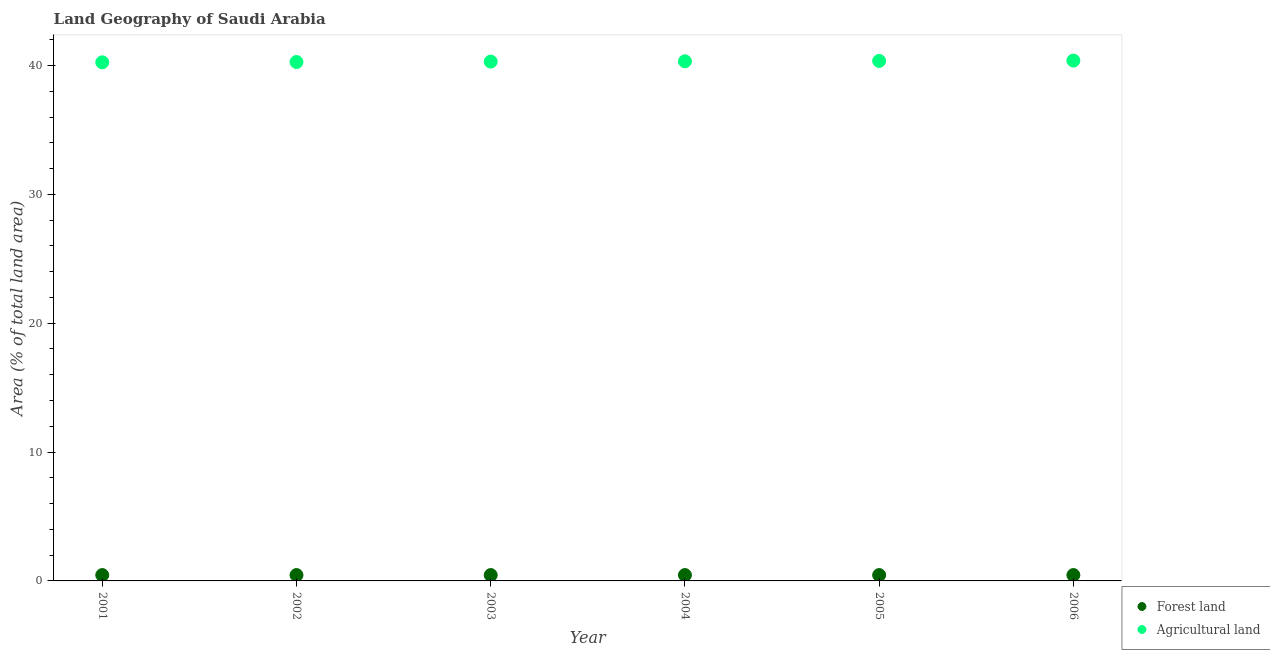What is the percentage of land area under forests in 2003?
Offer a terse response. 0.45. Across all years, what is the maximum percentage of land area under agriculture?
Make the answer very short. 40.38. Across all years, what is the minimum percentage of land area under agriculture?
Your answer should be very brief. 40.25. What is the total percentage of land area under forests in the graph?
Keep it short and to the point. 2.73. What is the difference between the percentage of land area under forests in 2003 and that in 2006?
Offer a very short reply. 0. What is the difference between the percentage of land area under agriculture in 2001 and the percentage of land area under forests in 2005?
Ensure brevity in your answer.  39.79. What is the average percentage of land area under agriculture per year?
Provide a succinct answer. 40.31. In the year 2006, what is the difference between the percentage of land area under forests and percentage of land area under agriculture?
Offer a very short reply. -39.93. What is the ratio of the percentage of land area under agriculture in 2002 to that in 2006?
Your response must be concise. 1. Is the percentage of land area under agriculture in 2003 less than that in 2004?
Ensure brevity in your answer.  Yes. Is the difference between the percentage of land area under agriculture in 2002 and 2005 greater than the difference between the percentage of land area under forests in 2002 and 2005?
Ensure brevity in your answer.  No. What is the difference between the highest and the lowest percentage of land area under forests?
Give a very brief answer. 0. In how many years, is the percentage of land area under agriculture greater than the average percentage of land area under agriculture taken over all years?
Your answer should be compact. 3. Is the percentage of land area under forests strictly greater than the percentage of land area under agriculture over the years?
Make the answer very short. No. How many years are there in the graph?
Your answer should be very brief. 6. Where does the legend appear in the graph?
Give a very brief answer. Bottom right. What is the title of the graph?
Your answer should be compact. Land Geography of Saudi Arabia. Does "Private credit bureau" appear as one of the legend labels in the graph?
Your response must be concise. No. What is the label or title of the X-axis?
Offer a very short reply. Year. What is the label or title of the Y-axis?
Offer a very short reply. Area (% of total land area). What is the Area (% of total land area) in Forest land in 2001?
Make the answer very short. 0.45. What is the Area (% of total land area) of Agricultural land in 2001?
Offer a terse response. 40.25. What is the Area (% of total land area) in Forest land in 2002?
Make the answer very short. 0.45. What is the Area (% of total land area) in Agricultural land in 2002?
Provide a succinct answer. 40.27. What is the Area (% of total land area) of Forest land in 2003?
Provide a short and direct response. 0.45. What is the Area (% of total land area) in Agricultural land in 2003?
Your response must be concise. 40.3. What is the Area (% of total land area) of Forest land in 2004?
Offer a terse response. 0.45. What is the Area (% of total land area) in Agricultural land in 2004?
Provide a short and direct response. 40.32. What is the Area (% of total land area) of Forest land in 2005?
Your answer should be very brief. 0.45. What is the Area (% of total land area) in Agricultural land in 2005?
Ensure brevity in your answer.  40.35. What is the Area (% of total land area) in Forest land in 2006?
Ensure brevity in your answer.  0.45. What is the Area (% of total land area) in Agricultural land in 2006?
Your answer should be very brief. 40.38. Across all years, what is the maximum Area (% of total land area) in Forest land?
Provide a succinct answer. 0.45. Across all years, what is the maximum Area (% of total land area) in Agricultural land?
Keep it short and to the point. 40.38. Across all years, what is the minimum Area (% of total land area) of Forest land?
Offer a terse response. 0.45. Across all years, what is the minimum Area (% of total land area) in Agricultural land?
Offer a very short reply. 40.25. What is the total Area (% of total land area) of Forest land in the graph?
Give a very brief answer. 2.73. What is the total Area (% of total land area) of Agricultural land in the graph?
Your answer should be very brief. 241.88. What is the difference between the Area (% of total land area) of Agricultural land in 2001 and that in 2002?
Give a very brief answer. -0.02. What is the difference between the Area (% of total land area) of Forest land in 2001 and that in 2003?
Give a very brief answer. 0. What is the difference between the Area (% of total land area) in Agricultural land in 2001 and that in 2003?
Offer a very short reply. -0.06. What is the difference between the Area (% of total land area) of Forest land in 2001 and that in 2004?
Your answer should be very brief. 0. What is the difference between the Area (% of total land area) of Agricultural land in 2001 and that in 2004?
Provide a succinct answer. -0.08. What is the difference between the Area (% of total land area) in Forest land in 2001 and that in 2005?
Your answer should be compact. 0. What is the difference between the Area (% of total land area) in Agricultural land in 2001 and that in 2005?
Offer a terse response. -0.11. What is the difference between the Area (% of total land area) in Agricultural land in 2001 and that in 2006?
Offer a very short reply. -0.13. What is the difference between the Area (% of total land area) in Forest land in 2002 and that in 2003?
Your answer should be compact. 0. What is the difference between the Area (% of total land area) of Agricultural land in 2002 and that in 2003?
Give a very brief answer. -0.03. What is the difference between the Area (% of total land area) in Agricultural land in 2002 and that in 2004?
Offer a very short reply. -0.05. What is the difference between the Area (% of total land area) in Forest land in 2002 and that in 2005?
Provide a short and direct response. 0. What is the difference between the Area (% of total land area) in Agricultural land in 2002 and that in 2005?
Make the answer very short. -0.08. What is the difference between the Area (% of total land area) of Forest land in 2002 and that in 2006?
Provide a short and direct response. 0. What is the difference between the Area (% of total land area) of Agricultural land in 2002 and that in 2006?
Your answer should be very brief. -0.11. What is the difference between the Area (% of total land area) in Agricultural land in 2003 and that in 2004?
Offer a terse response. -0.02. What is the difference between the Area (% of total land area) of Forest land in 2003 and that in 2005?
Give a very brief answer. 0. What is the difference between the Area (% of total land area) of Agricultural land in 2003 and that in 2005?
Ensure brevity in your answer.  -0.05. What is the difference between the Area (% of total land area) in Agricultural land in 2003 and that in 2006?
Make the answer very short. -0.08. What is the difference between the Area (% of total land area) in Agricultural land in 2004 and that in 2005?
Give a very brief answer. -0.03. What is the difference between the Area (% of total land area) in Agricultural land in 2004 and that in 2006?
Provide a short and direct response. -0.06. What is the difference between the Area (% of total land area) of Agricultural land in 2005 and that in 2006?
Make the answer very short. -0.03. What is the difference between the Area (% of total land area) in Forest land in 2001 and the Area (% of total land area) in Agricultural land in 2002?
Your answer should be very brief. -39.82. What is the difference between the Area (% of total land area) in Forest land in 2001 and the Area (% of total land area) in Agricultural land in 2003?
Give a very brief answer. -39.85. What is the difference between the Area (% of total land area) of Forest land in 2001 and the Area (% of total land area) of Agricultural land in 2004?
Offer a very short reply. -39.87. What is the difference between the Area (% of total land area) of Forest land in 2001 and the Area (% of total land area) of Agricultural land in 2005?
Provide a short and direct response. -39.9. What is the difference between the Area (% of total land area) of Forest land in 2001 and the Area (% of total land area) of Agricultural land in 2006?
Provide a short and direct response. -39.93. What is the difference between the Area (% of total land area) of Forest land in 2002 and the Area (% of total land area) of Agricultural land in 2003?
Keep it short and to the point. -39.85. What is the difference between the Area (% of total land area) of Forest land in 2002 and the Area (% of total land area) of Agricultural land in 2004?
Your response must be concise. -39.87. What is the difference between the Area (% of total land area) in Forest land in 2002 and the Area (% of total land area) in Agricultural land in 2005?
Ensure brevity in your answer.  -39.9. What is the difference between the Area (% of total land area) in Forest land in 2002 and the Area (% of total land area) in Agricultural land in 2006?
Your answer should be compact. -39.93. What is the difference between the Area (% of total land area) in Forest land in 2003 and the Area (% of total land area) in Agricultural land in 2004?
Make the answer very short. -39.87. What is the difference between the Area (% of total land area) of Forest land in 2003 and the Area (% of total land area) of Agricultural land in 2005?
Your answer should be compact. -39.9. What is the difference between the Area (% of total land area) of Forest land in 2003 and the Area (% of total land area) of Agricultural land in 2006?
Your answer should be very brief. -39.93. What is the difference between the Area (% of total land area) of Forest land in 2004 and the Area (% of total land area) of Agricultural land in 2005?
Your response must be concise. -39.9. What is the difference between the Area (% of total land area) of Forest land in 2004 and the Area (% of total land area) of Agricultural land in 2006?
Offer a terse response. -39.93. What is the difference between the Area (% of total land area) in Forest land in 2005 and the Area (% of total land area) in Agricultural land in 2006?
Ensure brevity in your answer.  -39.93. What is the average Area (% of total land area) of Forest land per year?
Offer a very short reply. 0.45. What is the average Area (% of total land area) of Agricultural land per year?
Provide a short and direct response. 40.31. In the year 2001, what is the difference between the Area (% of total land area) of Forest land and Area (% of total land area) of Agricultural land?
Offer a very short reply. -39.79. In the year 2002, what is the difference between the Area (% of total land area) of Forest land and Area (% of total land area) of Agricultural land?
Offer a very short reply. -39.82. In the year 2003, what is the difference between the Area (% of total land area) of Forest land and Area (% of total land area) of Agricultural land?
Keep it short and to the point. -39.85. In the year 2004, what is the difference between the Area (% of total land area) of Forest land and Area (% of total land area) of Agricultural land?
Keep it short and to the point. -39.87. In the year 2005, what is the difference between the Area (% of total land area) of Forest land and Area (% of total land area) of Agricultural land?
Provide a short and direct response. -39.9. In the year 2006, what is the difference between the Area (% of total land area) in Forest land and Area (% of total land area) in Agricultural land?
Your answer should be very brief. -39.93. What is the ratio of the Area (% of total land area) in Agricultural land in 2001 to that in 2002?
Your answer should be very brief. 1. What is the ratio of the Area (% of total land area) of Forest land in 2001 to that in 2003?
Provide a short and direct response. 1. What is the ratio of the Area (% of total land area) in Agricultural land in 2001 to that in 2003?
Offer a very short reply. 1. What is the ratio of the Area (% of total land area) in Forest land in 2001 to that in 2004?
Make the answer very short. 1. What is the ratio of the Area (% of total land area) of Agricultural land in 2001 to that in 2004?
Ensure brevity in your answer.  1. What is the ratio of the Area (% of total land area) in Forest land in 2001 to that in 2006?
Offer a very short reply. 1. What is the ratio of the Area (% of total land area) of Agricultural land in 2002 to that in 2003?
Your answer should be very brief. 1. What is the ratio of the Area (% of total land area) in Agricultural land in 2003 to that in 2004?
Your answer should be compact. 1. What is the ratio of the Area (% of total land area) of Agricultural land in 2003 to that in 2005?
Keep it short and to the point. 1. What is the ratio of the Area (% of total land area) in Forest land in 2004 to that in 2005?
Offer a very short reply. 1. What is the ratio of the Area (% of total land area) in Agricultural land in 2004 to that in 2005?
Offer a very short reply. 1. What is the ratio of the Area (% of total land area) in Agricultural land in 2004 to that in 2006?
Offer a terse response. 1. What is the ratio of the Area (% of total land area) of Forest land in 2005 to that in 2006?
Your answer should be very brief. 1. What is the ratio of the Area (% of total land area) in Agricultural land in 2005 to that in 2006?
Ensure brevity in your answer.  1. What is the difference between the highest and the second highest Area (% of total land area) in Forest land?
Provide a succinct answer. 0. What is the difference between the highest and the second highest Area (% of total land area) of Agricultural land?
Keep it short and to the point. 0.03. What is the difference between the highest and the lowest Area (% of total land area) of Agricultural land?
Make the answer very short. 0.13. 